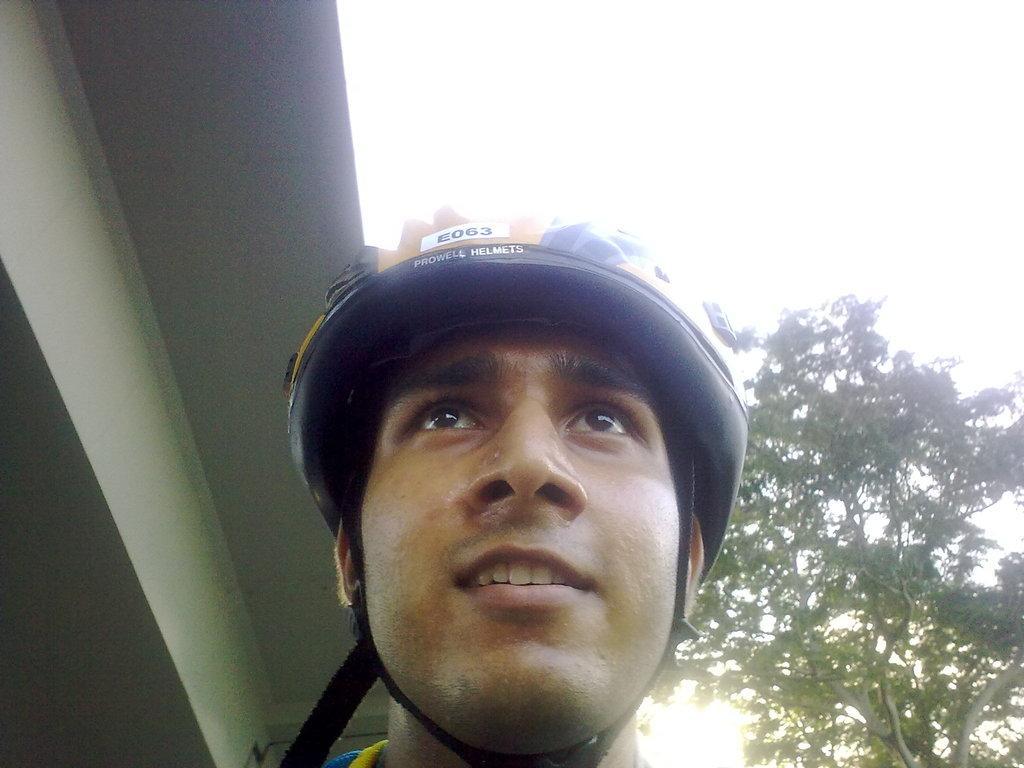Describe this image in one or two sentences. In this image we can see a person wearing helmet. On the left side there is a roof. On the right side there is tree. Also there is sky. 